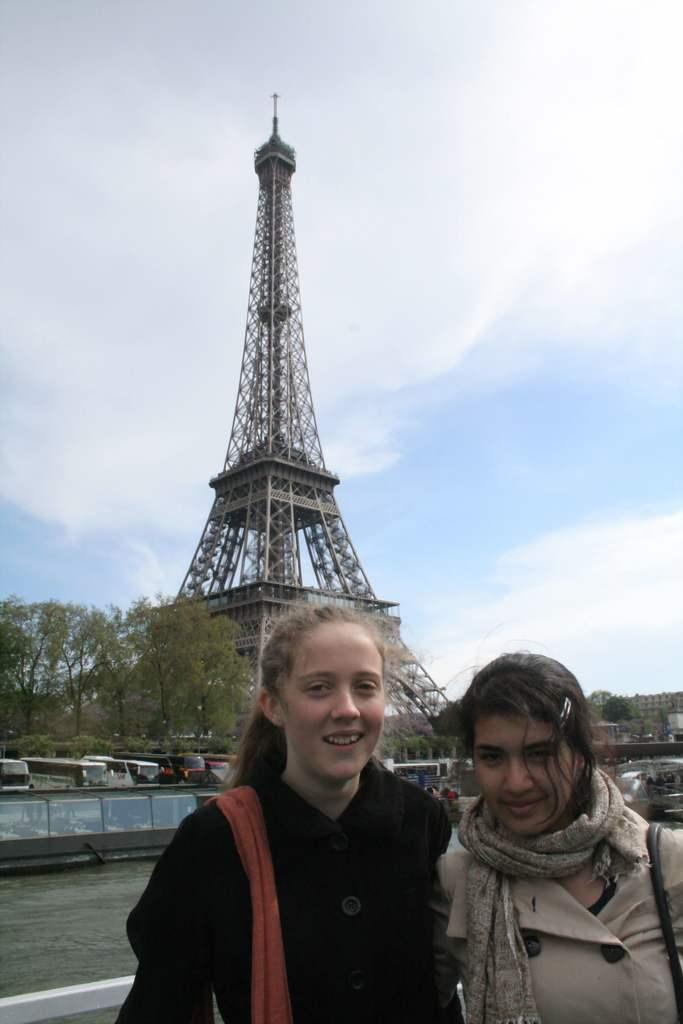How many women are in the image? There are two women in the image. What are the women doing in the image? The women are standing and carrying bags on their shoulders. What can be seen in the background of the image? There are vehicles, trees, buildings, and clouds in the sky in the background of the image. What famous landmark is visible in the background of the image? The Eiffel Tower is visible in the background of the image. What type of stem can be seen in the library in the image? There is no library or stem present in the image. How does the cough of the woman affect the other woman in the image? There is no cough or indication of illness in the image. 